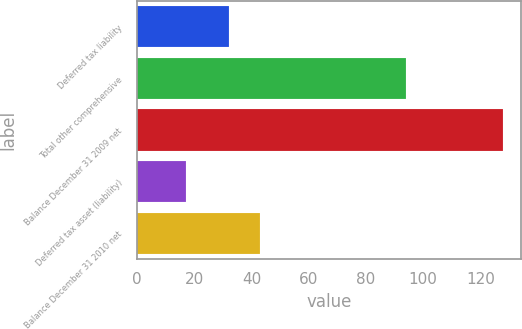Convert chart to OTSL. <chart><loc_0><loc_0><loc_500><loc_500><bar_chart><fcel>Deferred tax liability<fcel>Total other comprehensive<fcel>Balance December 31 2009 net<fcel>Deferred tax asset (liability)<fcel>Balance December 31 2010 net<nl><fcel>32<fcel>94<fcel>128<fcel>17<fcel>43.1<nl></chart> 